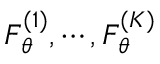<formula> <loc_0><loc_0><loc_500><loc_500>F _ { \theta } ^ { ( 1 ) } , \cdots , F _ { \theta } ^ { ( K ) }</formula> 